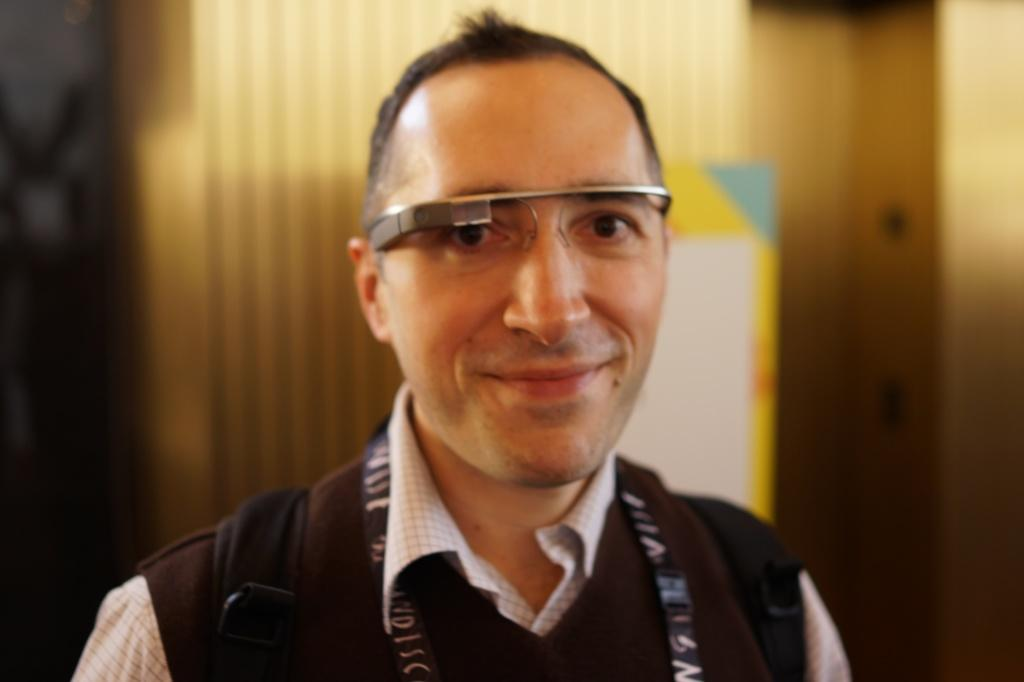What is the main subject of the image? There is a person in the image. What is the person wearing? The person is wearing a white check shirt. What is the person doing in the image? The person is standing and smiling. What can be seen in the background of the image? There is a board on the wall in the background of the image. What type of beetle can be seen crawling on the person's shirt in the image? There is no beetle present on the person's shirt in the image. How many stamps are visible on the board in the background of the image? The provided facts do not mention any stamps on the board in the background, so we cannot determine the number of stamps. 